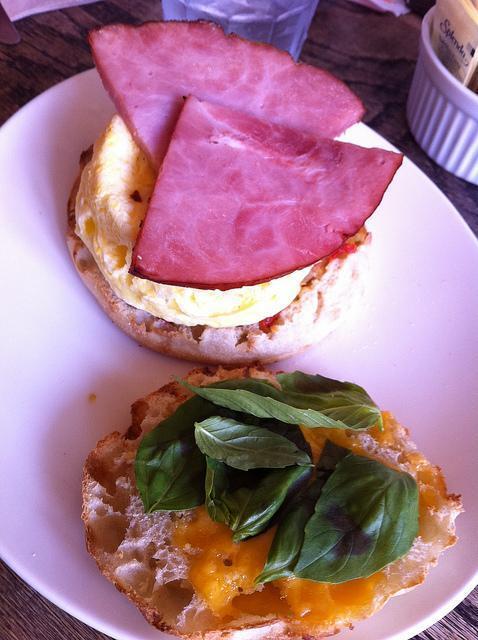How many pieces of ham are on the plate?
Give a very brief answer. 2. How many sandwiches are in the photo?
Give a very brief answer. 2. How many bowls can be seen?
Give a very brief answer. 2. How many zebras are drinking water?
Give a very brief answer. 0. 